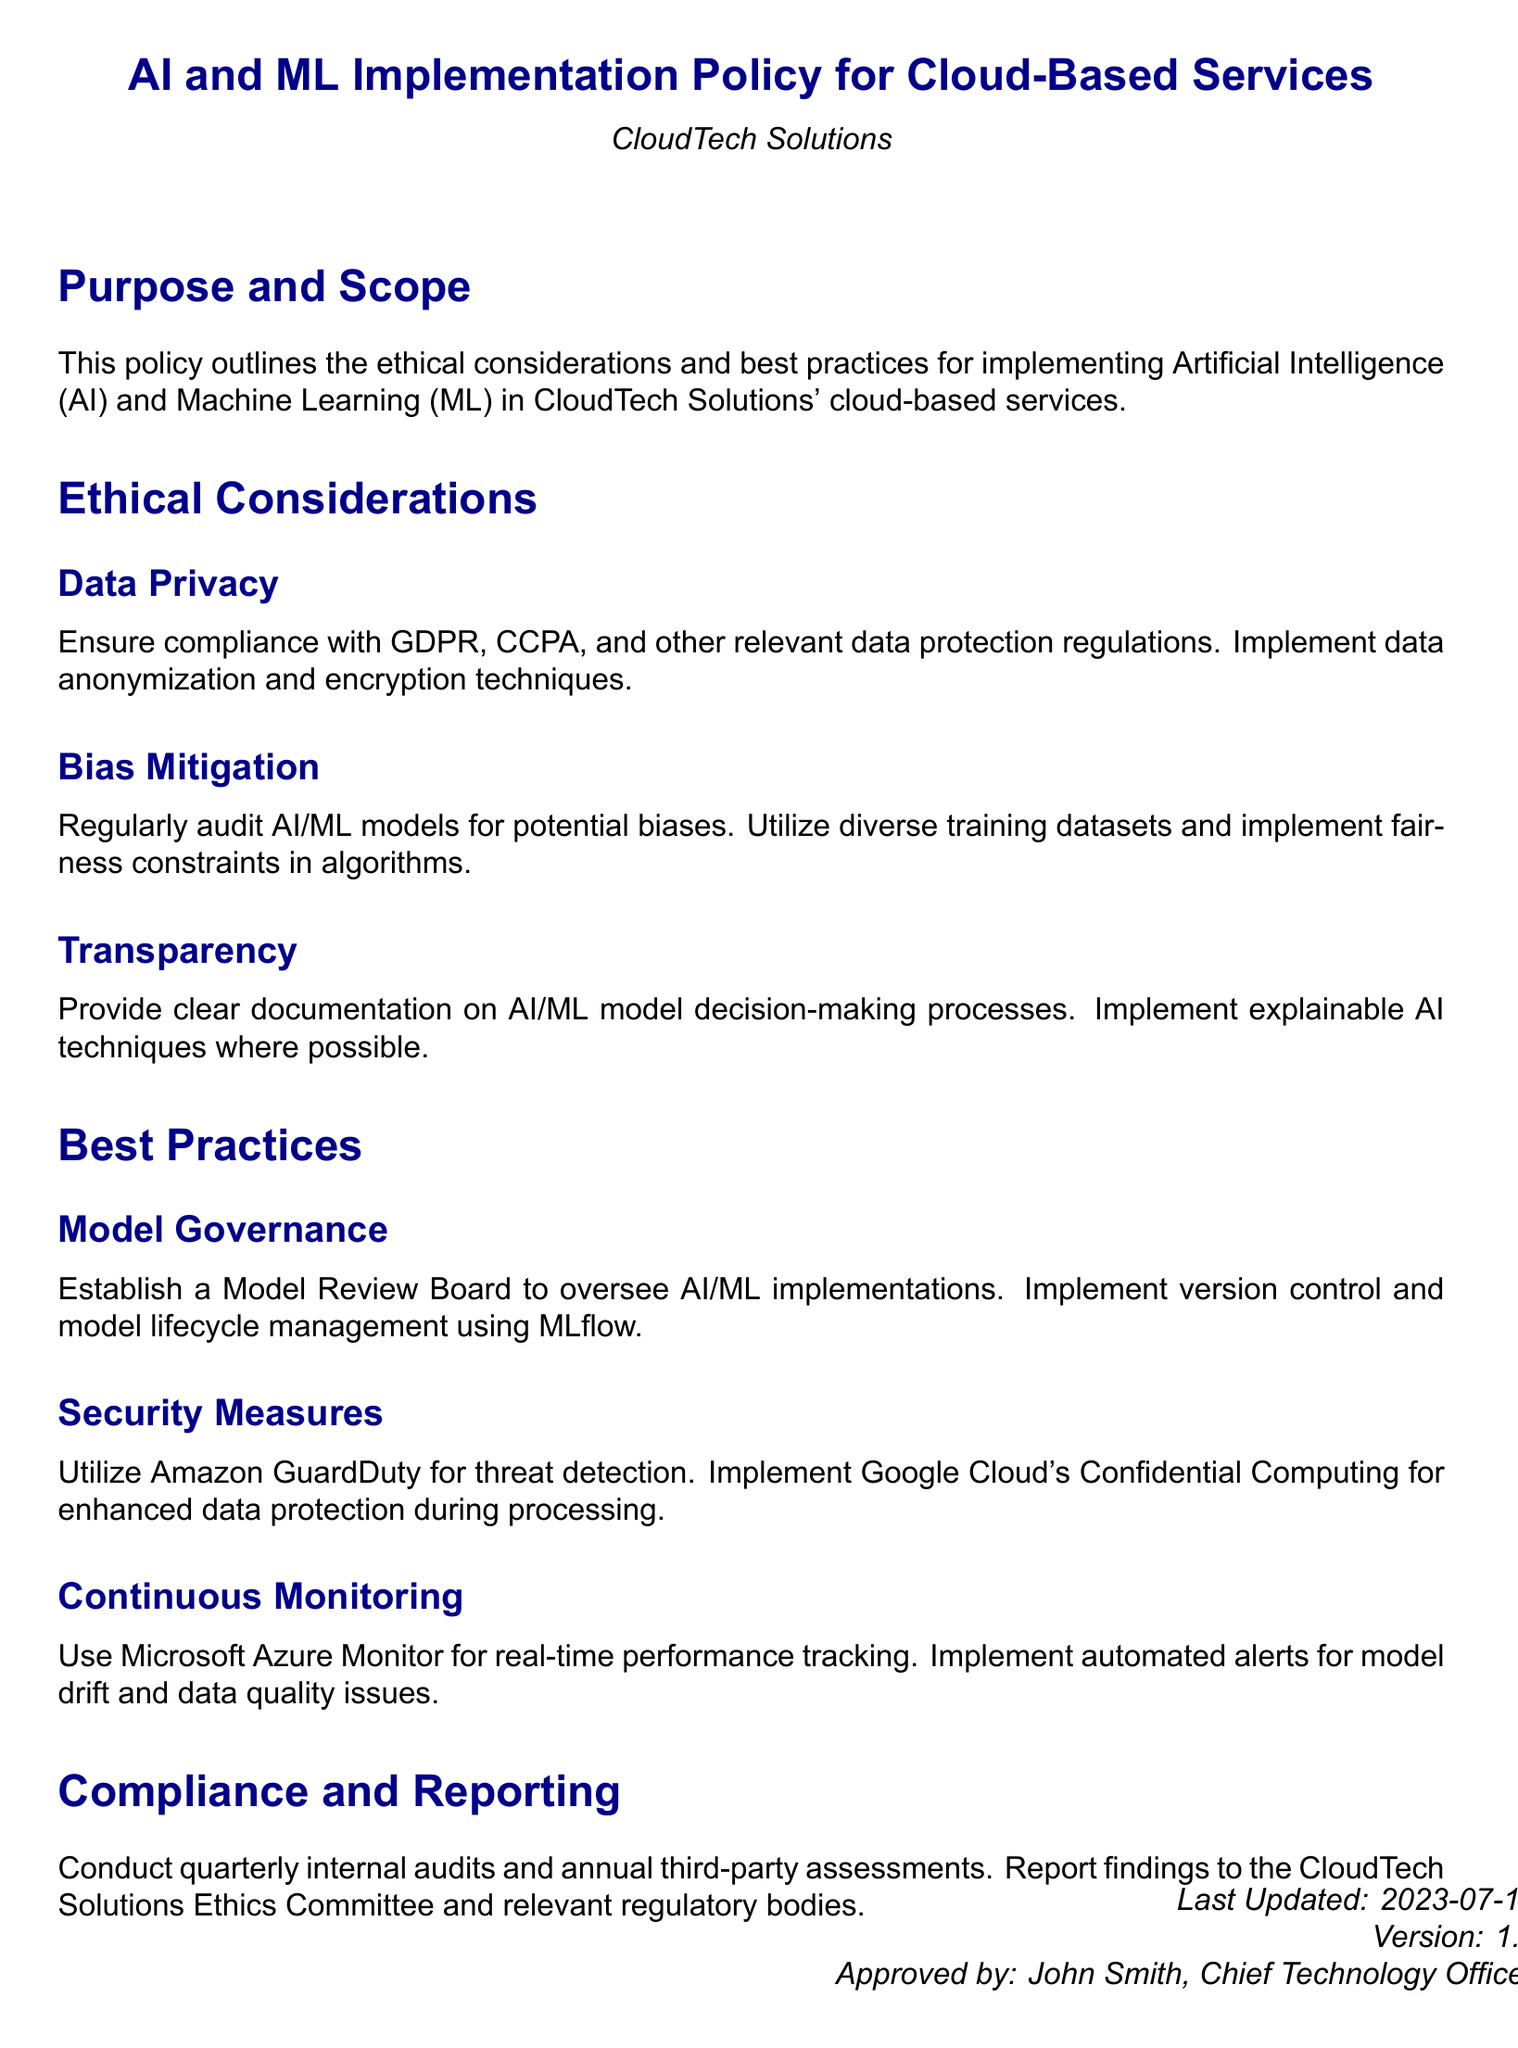What is the main purpose of the policy? The purpose is to outline the ethical considerations and best practices for implementing AI and ML in CloudTech Solutions' cloud-based services.
Answer: To outline ethical considerations and best practices What is one ethical consideration mentioned in the document? The document lists several ethical considerations, including data privacy, bias mitigation, and transparency.
Answer: Data privacy What technology is suggested for threat detection? The document recommends using Amazon GuardDuty for threat detection.
Answer: Amazon GuardDuty When was the document last updated? The last updated date is provided in the footer of the document.
Answer: 2023-07-15 How often should internal audits be conducted? The policy states that internal audits should be conducted quarterly.
Answer: Quarterly What is the role of the Model Review Board? The Model Review Board is responsible for overseeing AI/ML implementations in the organization.
Answer: Oversee AI/ML implementations What is one method mentioned for mitigating bias? Regular audits and the use of diverse training datasets are mentioned as methods for mitigating bias.
Answer: Diverse training datasets Which cloud provider's service is recommended for enhanced data protection during processing? The policy suggests implementing Google Cloud's Confidential Computing for enhanced data protection.
Answer: Google Cloud's Confidential Computing What is the version number of the document? The version number is stated in the footer section of the document.
Answer: 1.2 